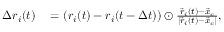Convert formula to latex. <formula><loc_0><loc_0><loc_500><loc_500>\begin{array} { r l } { \Delta r _ { i } ( t ) } & = \left ( r _ { i } ( t ) - r _ { i } ( t - \Delta t ) \right ) \odot \frac { \vec { r } _ { i } ( t ) - \vec { x } _ { c } } { | \vec { r } _ { i } ( t ) - \vec { x } _ { c } | } , } \end{array}</formula> 